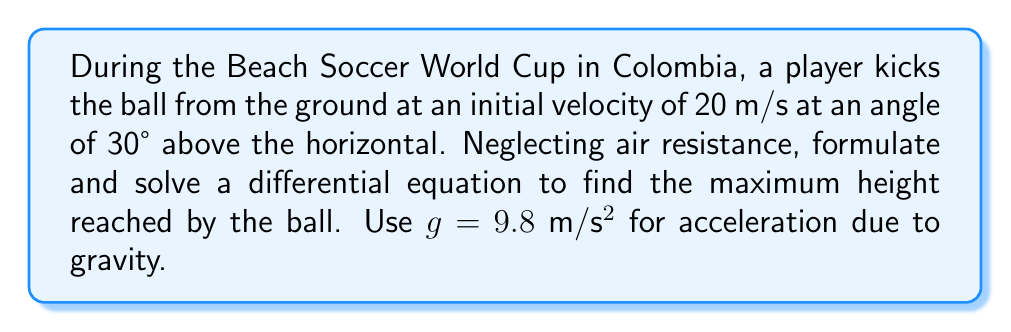Help me with this question. Let's approach this step-by-step:

1) First, we need to set up our coordinate system. Let's use $x$ for horizontal distance and $y$ for vertical height.

2) The initial velocity components are:
   $v_x = 20 \cos(30°) = 20 \cdot \frac{\sqrt{3}}{2} = 10\sqrt{3}$ m/s
   $v_y = 20 \sin(30°) = 20 \cdot \frac{1}{2} = 10$ m/s

3) The equations of motion for $x$ and $y$ are:
   $x(t) = (10\sqrt{3})t$
   $y(t) = 10t - \frac{1}{2}gt^2 = 10t - 4.9t^2$

4) To find the maximum height, we need to find when the vertical velocity is zero:
   $\frac{dy}{dt} = 10 - 9.8t = 0$
   $t = \frac{10}{9.8} \approx 1.02$ seconds

5) Now, we can formulate our differential equation. The trajectory of the ball follows a parabolic path, which can be described by:

   $\frac{d^2y}{dx^2} = -\frac{g}{v_x^2}$

6) Substituting our known values:

   $\frac{d^2y}{dx^2} = -\frac{9.8}{(10\sqrt{3})^2} = -\frac{9.8}{300} \approx -0.0327$

7) Integrating twice:

   $\frac{dy}{dx} = -0.0327x + C_1$
   $y = -0.01635x^2 + C_1x + C_2$

8) Using initial conditions ($(0,0)$ and $\tan(30°) = \frac{1}{\sqrt{3}}$), we can solve for $C_1$ and $C_2$:

   $C_1 = \frac{1}{\sqrt{3}} \approx 0.577$
   $C_2 = 0$

9) Therefore, the equation of the trajectory is:

   $y = -0.01635x^2 + 0.577x$

10) To find the maximum height, we can use the time we calculated earlier:

    $y_{max} = 10(1.02) - 4.9(1.02)^2 \approx 5.1$ meters
Answer: The maximum height reached by the ball is approximately 5.1 meters. 